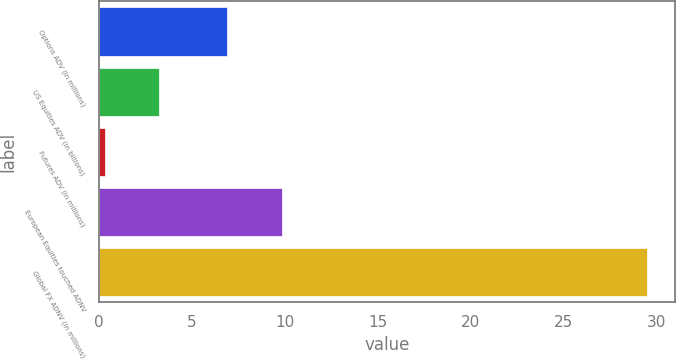Convert chart. <chart><loc_0><loc_0><loc_500><loc_500><bar_chart><fcel>Options ADV (in millions)<fcel>US Equities ADV (in billions)<fcel>Futures ADV (in millions)<fcel>European Equities touched ADNV<fcel>Global FX ADNV (in millions)<nl><fcel>6.9<fcel>3.22<fcel>0.3<fcel>9.82<fcel>29.5<nl></chart> 